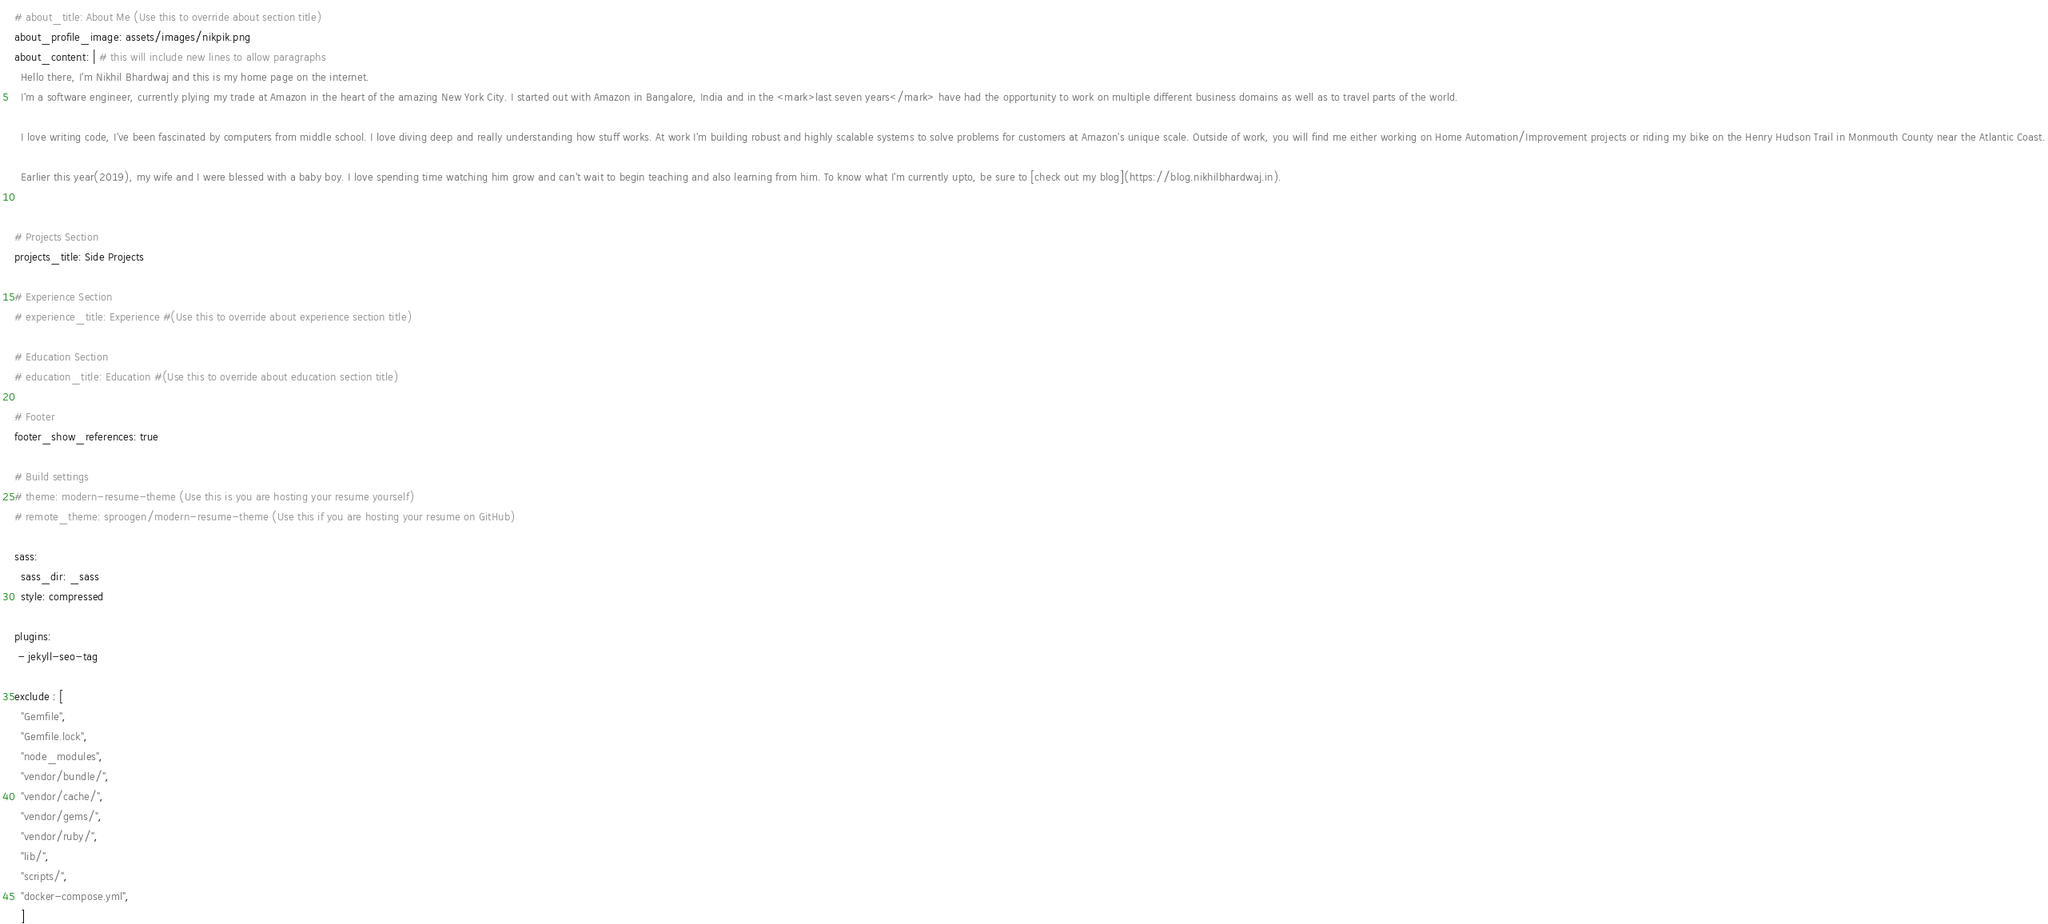<code> <loc_0><loc_0><loc_500><loc_500><_YAML_># about_title: About Me (Use this to override about section title)
about_profile_image: assets/images/nikpik.png
about_content: | # this will include new lines to allow paragraphs
  Hello there, I'm Nikhil Bhardwaj and this is my home page on the internet.
  I'm a software engineer, currently plying my trade at Amazon in the heart of the amazing New York City. I started out with Amazon in Bangalore, India and in the <mark>last seven years</mark> have had the opportunity to work on multiple different business domains as well as to travel parts of the world.

  I love writing code, I've been fascinated by computers from middle school. I love diving deep and really understanding how stuff works. At work I'm building robust and highly scalable systems to solve problems for customers at Amazon's unique scale. Outside of work, you will find me either working on Home Automation/Improvement projects or riding my bike on the Henry Hudson Trail in Monmouth County near the Atlantic Coast.

  Earlier this year(2019), my wife and I were blessed with a baby boy. I love spending time watching him grow and can't wait to begin teaching and also learning from him. To know what I'm currently upto, be sure to [check out my blog](https://blog.nikhilbhardwaj.in).


# Projects Section
projects_title: Side Projects

# Experience Section
# experience_title: Experience #(Use this to override about experience section title)

# Education Section
# education_title: Education #(Use this to override about education section title)

# Footer
footer_show_references: true

# Build settings
# theme: modern-resume-theme (Use this is you are hosting your resume yourself)
# remote_theme: sproogen/modern-resume-theme (Use this if you are hosting your resume on GitHub)

sass:
  sass_dir: _sass
  style: compressed

plugins:
 - jekyll-seo-tag

exclude : [
  "Gemfile",
  "Gemfile.lock",
  "node_modules",
  "vendor/bundle/",
  "vendor/cache/",
  "vendor/gems/",
  "vendor/ruby/",
  "lib/",
  "scripts/",
  "docker-compose.yml",
  ]
</code> 